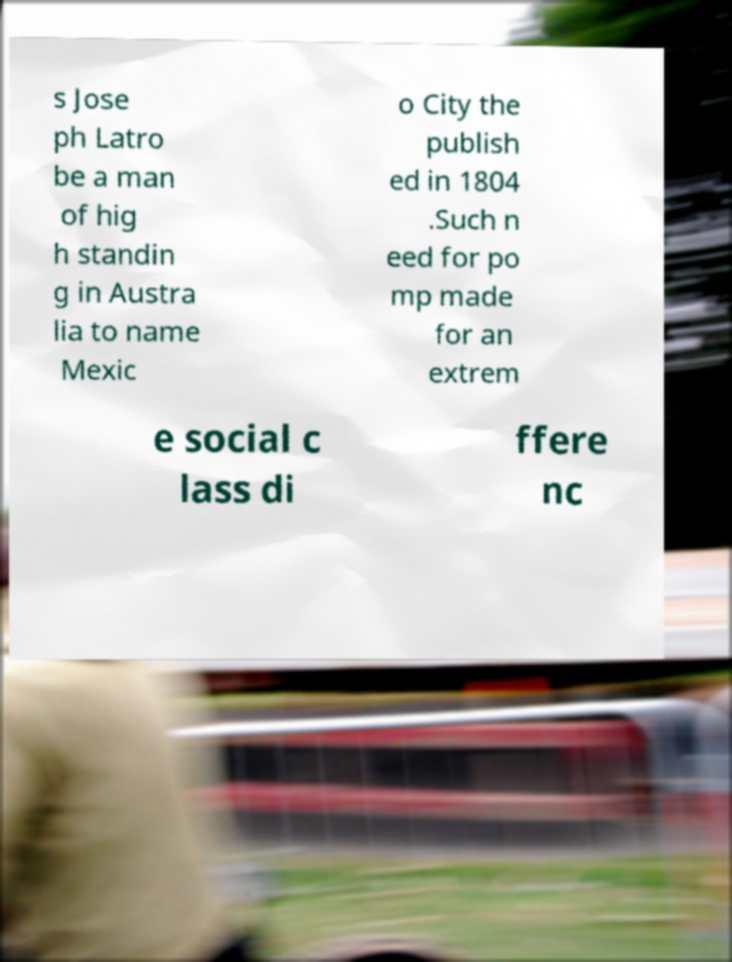There's text embedded in this image that I need extracted. Can you transcribe it verbatim? s Jose ph Latro be a man of hig h standin g in Austra lia to name Mexic o City the publish ed in 1804 .Such n eed for po mp made for an extrem e social c lass di ffere nc 